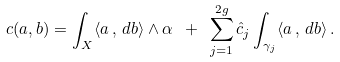<formula> <loc_0><loc_0><loc_500><loc_500>c ( a , b ) = \int _ { X } \langle a \, , \, d b \rangle \wedge \alpha \ + \ \sum _ { j = 1 } ^ { 2 g } \hat { c } _ { j } \int _ { \gamma _ { j } } \langle a \, , \, d b \rangle \, .</formula> 